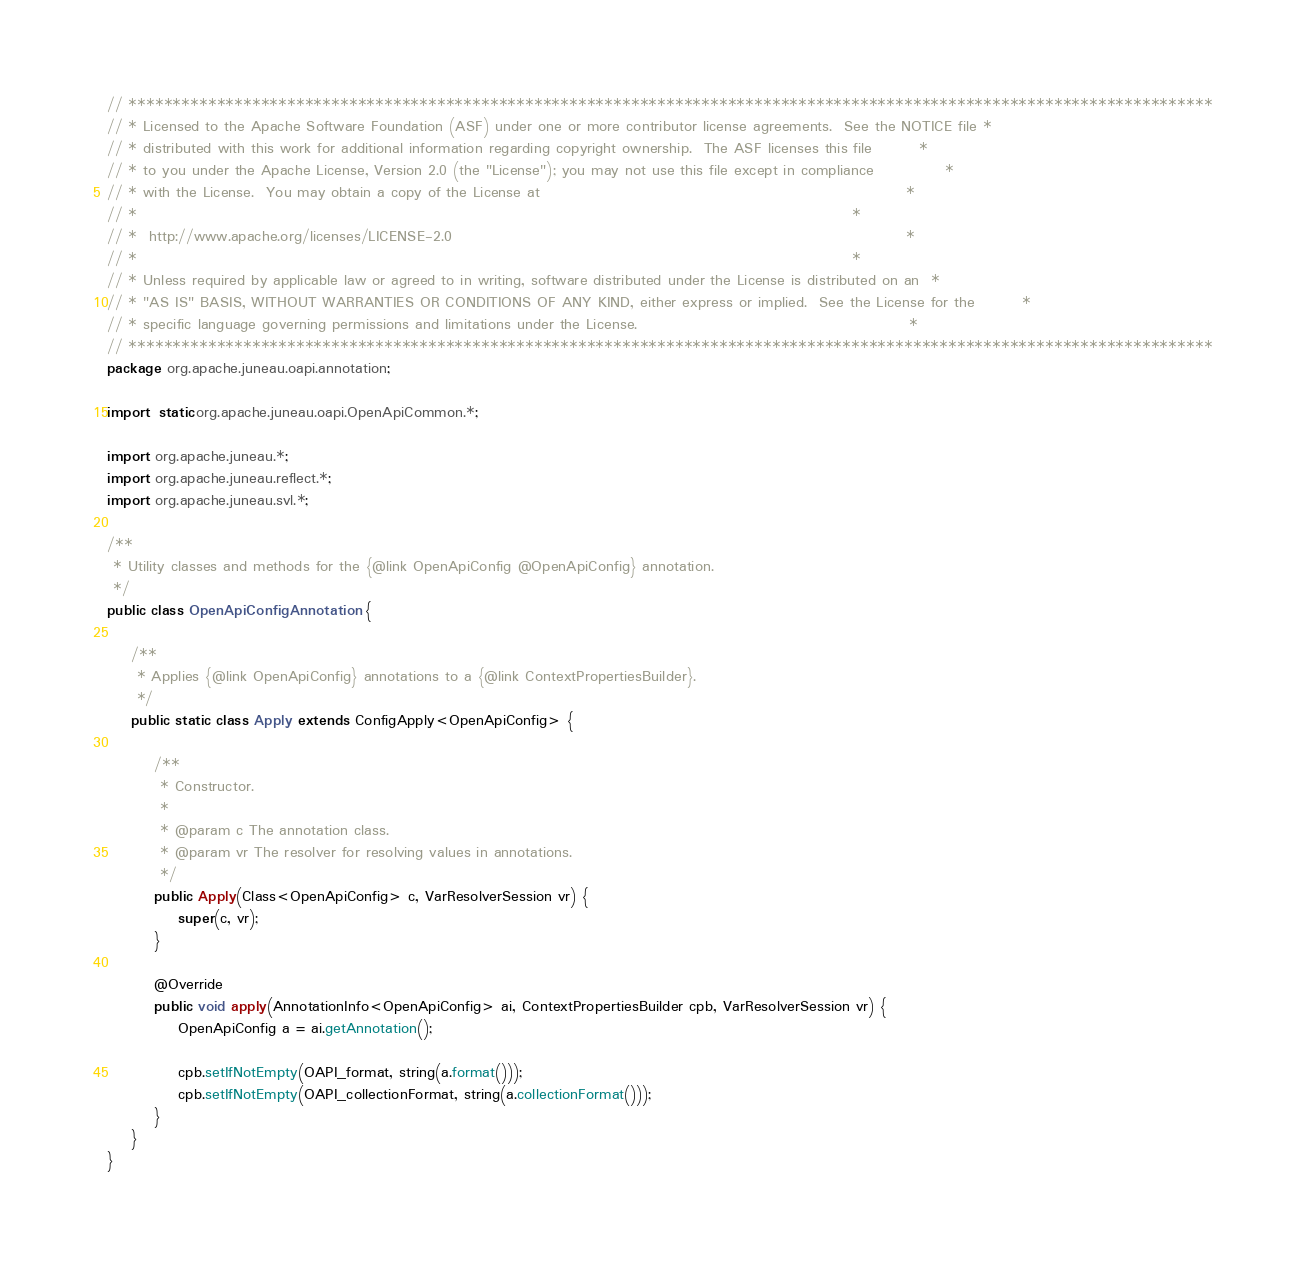<code> <loc_0><loc_0><loc_500><loc_500><_Java_>// ***************************************************************************************************************************
// * Licensed to the Apache Software Foundation (ASF) under one or more contributor license agreements.  See the NOTICE file *
// * distributed with this work for additional information regarding copyright ownership.  The ASF licenses this file        *
// * to you under the Apache License, Version 2.0 (the "License"); you may not use this file except in compliance            *
// * with the License.  You may obtain a copy of the License at                                                              *
// *                                                                                                                         *
// *  http://www.apache.org/licenses/LICENSE-2.0                                                                             *
// *                                                                                                                         *
// * Unless required by applicable law or agreed to in writing, software distributed under the License is distributed on an  *
// * "AS IS" BASIS, WITHOUT WARRANTIES OR CONDITIONS OF ANY KIND, either express or implied.  See the License for the        *
// * specific language governing permissions and limitations under the License.                                              *
// ***************************************************************************************************************************
package org.apache.juneau.oapi.annotation;

import static org.apache.juneau.oapi.OpenApiCommon.*;

import org.apache.juneau.*;
import org.apache.juneau.reflect.*;
import org.apache.juneau.svl.*;

/**
 * Utility classes and methods for the {@link OpenApiConfig @OpenApiConfig} annotation.
 */
public class OpenApiConfigAnnotation {

	/**
	 * Applies {@link OpenApiConfig} annotations to a {@link ContextPropertiesBuilder}.
	 */
	public static class Apply extends ConfigApply<OpenApiConfig> {

		/**
		 * Constructor.
		 *
		 * @param c The annotation class.
		 * @param vr The resolver for resolving values in annotations.
		 */
		public Apply(Class<OpenApiConfig> c, VarResolverSession vr) {
			super(c, vr);
		}

		@Override
		public void apply(AnnotationInfo<OpenApiConfig> ai, ContextPropertiesBuilder cpb, VarResolverSession vr) {
			OpenApiConfig a = ai.getAnnotation();

			cpb.setIfNotEmpty(OAPI_format, string(a.format()));
			cpb.setIfNotEmpty(OAPI_collectionFormat, string(a.collectionFormat()));
		}
	}
}</code> 